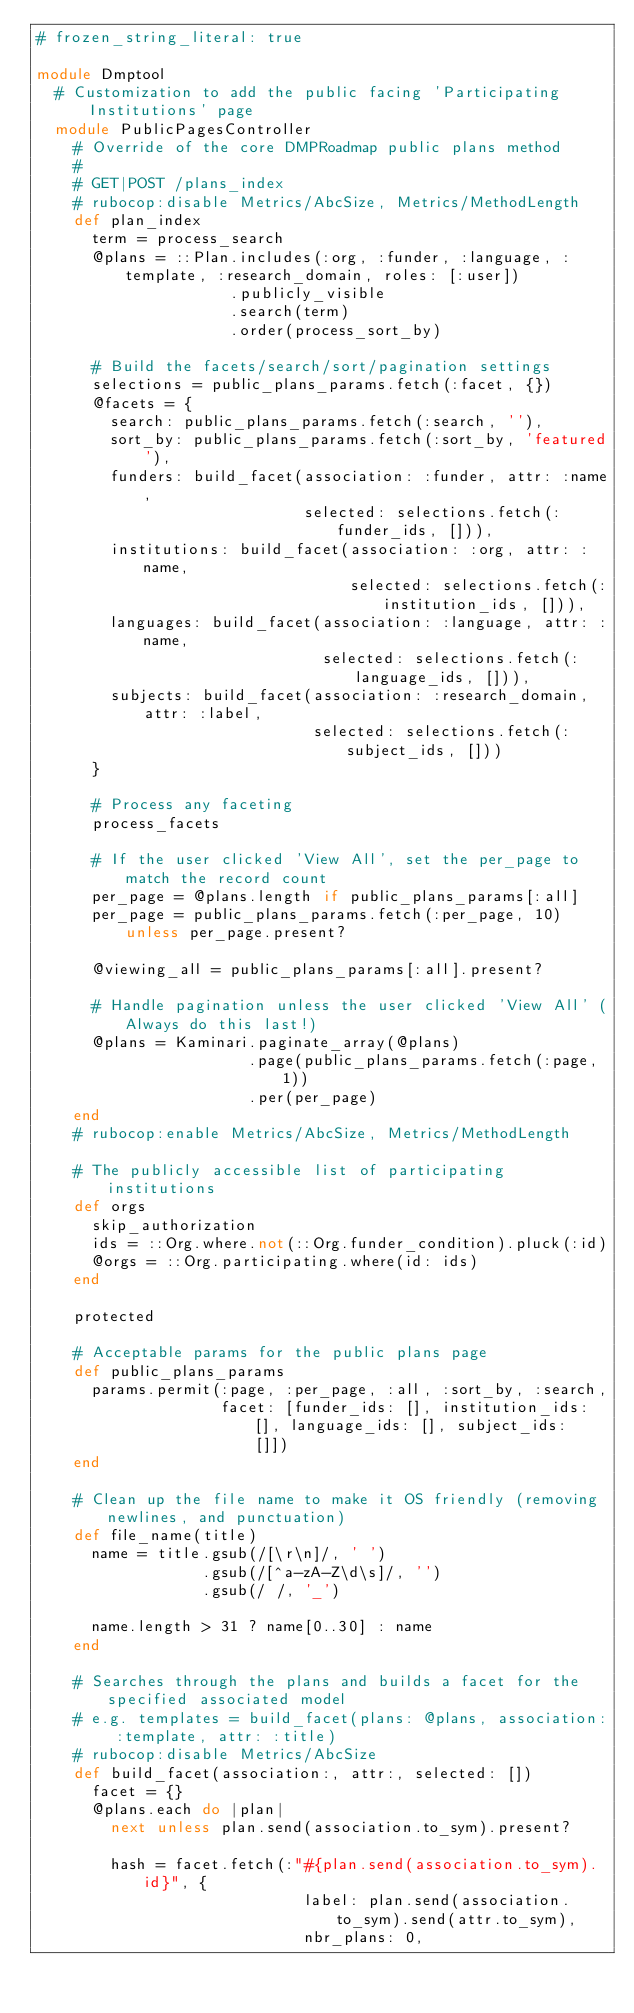Convert code to text. <code><loc_0><loc_0><loc_500><loc_500><_Ruby_># frozen_string_literal: true

module Dmptool
  # Customization to add the public facing 'Participating Institutions' page
  module PublicPagesController
    # Override of the core DMPRoadmap public plans method
    #
    # GET|POST /plans_index
    # rubocop:disable Metrics/AbcSize, Metrics/MethodLength
    def plan_index
      term = process_search
      @plans = ::Plan.includes(:org, :funder, :language, :template, :research_domain, roles: [:user])
                     .publicly_visible
                     .search(term)
                     .order(process_sort_by)

      # Build the facets/search/sort/pagination settings
      selections = public_plans_params.fetch(:facet, {})
      @facets = {
        search: public_plans_params.fetch(:search, ''),
        sort_by: public_plans_params.fetch(:sort_by, 'featured'),
        funders: build_facet(association: :funder, attr: :name,
                             selected: selections.fetch(:funder_ids, [])),
        institutions: build_facet(association: :org, attr: :name,
                                  selected: selections.fetch(:institution_ids, [])),
        languages: build_facet(association: :language, attr: :name,
                               selected: selections.fetch(:language_ids, [])),
        subjects: build_facet(association: :research_domain, attr: :label,
                              selected: selections.fetch(:subject_ids, []))
      }

      # Process any faceting
      process_facets

      # If the user clicked 'View All', set the per_page to match the record count
      per_page = @plans.length if public_plans_params[:all]
      per_page = public_plans_params.fetch(:per_page, 10) unless per_page.present?

      @viewing_all = public_plans_params[:all].present?

      # Handle pagination unless the user clicked 'View All' (Always do this last!)
      @plans = Kaminari.paginate_array(@plans)
                       .page(public_plans_params.fetch(:page, 1))
                       .per(per_page)
    end
    # rubocop:enable Metrics/AbcSize, Metrics/MethodLength

    # The publicly accessible list of participating institutions
    def orgs
      skip_authorization
      ids = ::Org.where.not(::Org.funder_condition).pluck(:id)
      @orgs = ::Org.participating.where(id: ids)
    end

    protected

    # Acceptable params for the public plans page
    def public_plans_params
      params.permit(:page, :per_page, :all, :sort_by, :search,
                    facet: [funder_ids: [], institution_ids: [], language_ids: [], subject_ids: []])
    end

    # Clean up the file name to make it OS friendly (removing newlines, and punctuation)
    def file_name(title)
      name = title.gsub(/[\r\n]/, ' ')
                  .gsub(/[^a-zA-Z\d\s]/, '')
                  .gsub(/ /, '_')

      name.length > 31 ? name[0..30] : name
    end

    # Searches through the plans and builds a facet for the specified associated model
    # e.g. templates = build_facet(plans: @plans, association: :template, attr: :title)
    # rubocop:disable Metrics/AbcSize
    def build_facet(association:, attr:, selected: [])
      facet = {}
      @plans.each do |plan|
        next unless plan.send(association.to_sym).present?

        hash = facet.fetch(:"#{plan.send(association.to_sym).id}", {
                             label: plan.send(association.to_sym).send(attr.to_sym),
                             nbr_plans: 0,</code> 